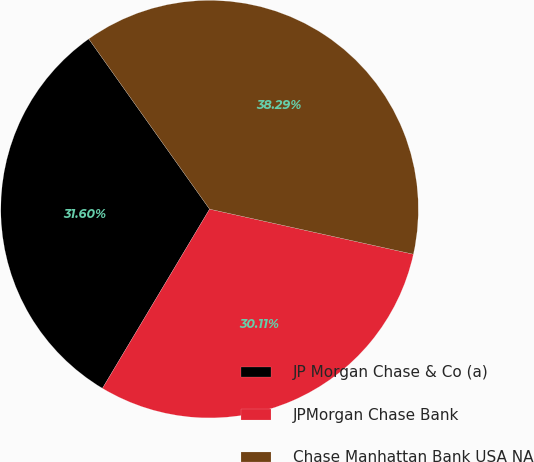Convert chart. <chart><loc_0><loc_0><loc_500><loc_500><pie_chart><fcel>JP Morgan Chase & Co (a)<fcel>JPMorgan Chase Bank<fcel>Chase Manhattan Bank USA NA<nl><fcel>31.6%<fcel>30.11%<fcel>38.29%<nl></chart> 